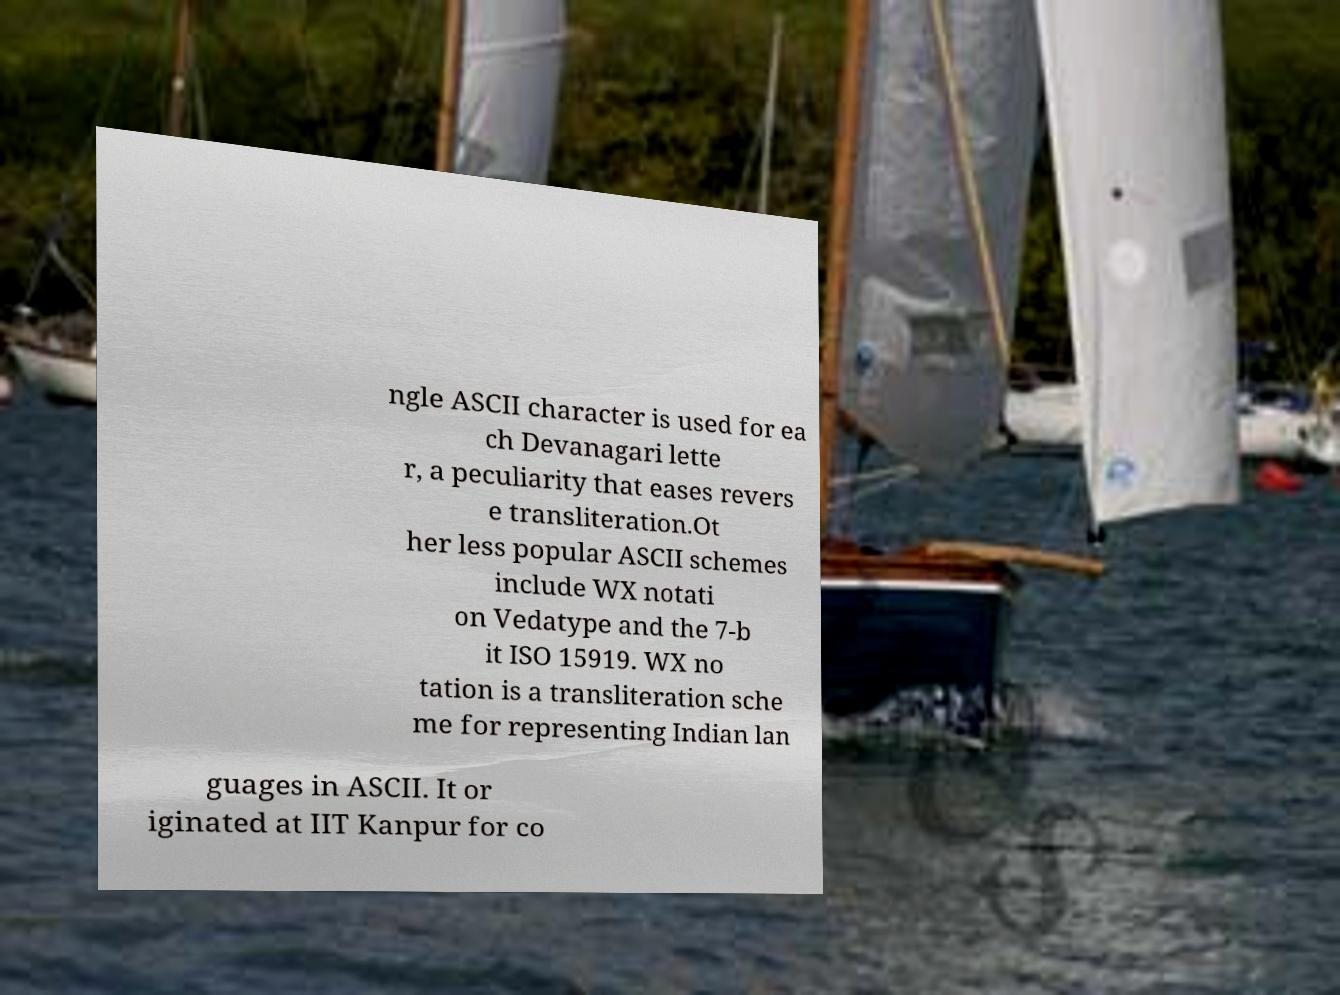There's text embedded in this image that I need extracted. Can you transcribe it verbatim? ngle ASCII character is used for ea ch Devanagari lette r, a peculiarity that eases revers e transliteration.Ot her less popular ASCII schemes include WX notati on Vedatype and the 7-b it ISO 15919. WX no tation is a transliteration sche me for representing Indian lan guages in ASCII. It or iginated at IIT Kanpur for co 